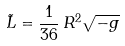<formula> <loc_0><loc_0><loc_500><loc_500>\tilde { L } = \frac { 1 } { 3 6 } \, R ^ { 2 } \sqrt { - g }</formula> 